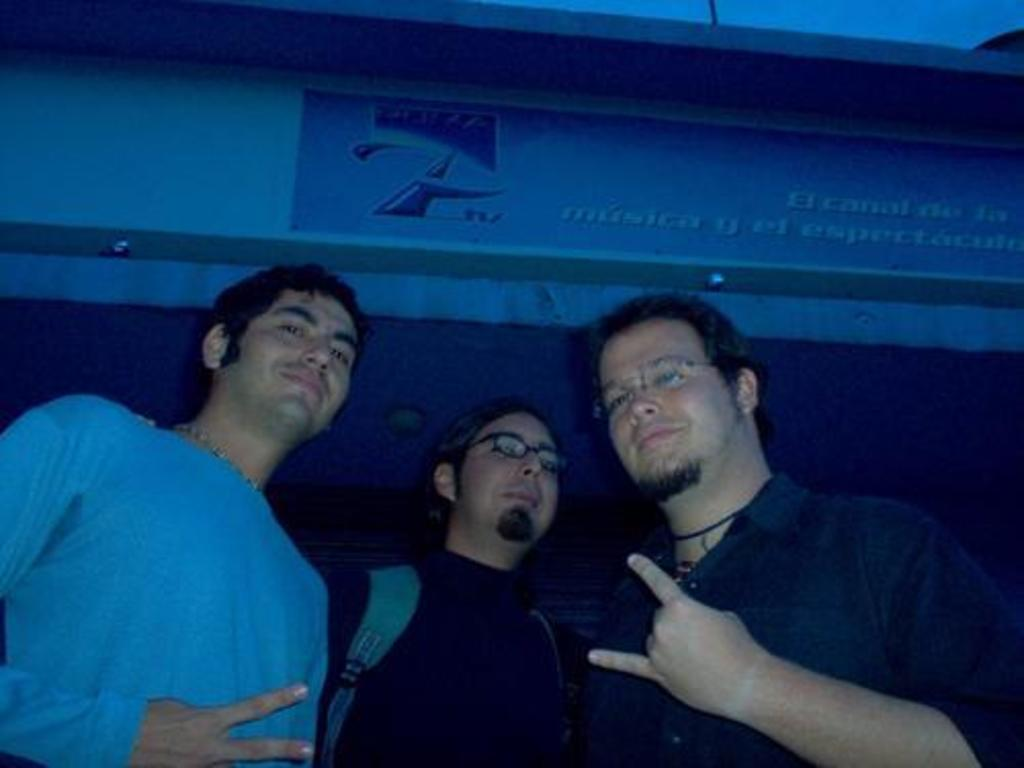How many people are in the foreground of the image? There are three people in the foreground of the image. What can be seen in the background of the image? There is a building in the background of the image. Can you describe any additional elements in the image? Yes, there is a banner visible in the image. Are there any fairies visible in the image? No, there are no fairies present in the image. 